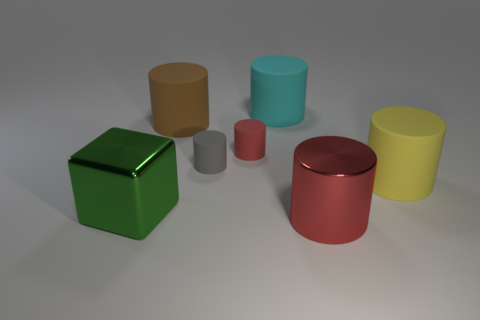Subtract all large brown rubber cylinders. How many cylinders are left? 5 Subtract 1 cylinders. How many cylinders are left? 5 Add 3 big brown rubber things. How many objects exist? 10 Subtract all gray cylinders. How many cylinders are left? 5 Subtract all cyan cylinders. Subtract all red spheres. How many cylinders are left? 5 Subtract all blocks. How many objects are left? 6 Add 7 large green objects. How many large green objects are left? 8 Add 7 big brown rubber things. How many big brown rubber things exist? 8 Subtract 0 red blocks. How many objects are left? 7 Subtract all small red metallic cylinders. Subtract all tiny gray rubber cylinders. How many objects are left? 6 